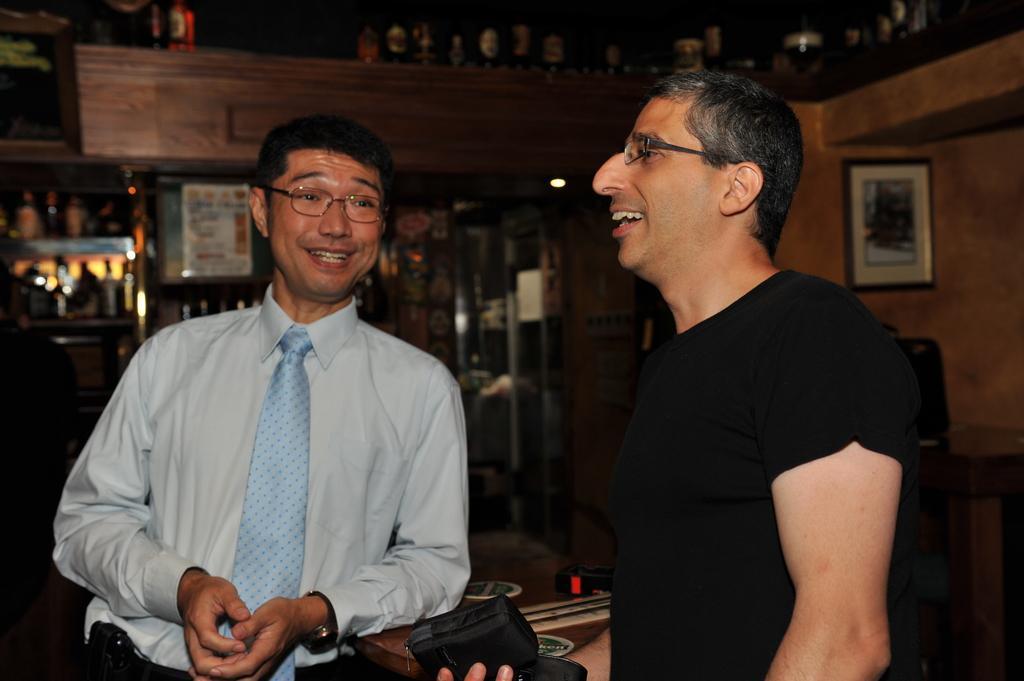How would you summarize this image in a sentence or two? In this picture there is a man who is wearing spectacles, shirt and tie. On the right there is a man who is wearing t-shirt and spectacle. Both of them are smiling. On the table I can see the stickers and other objects. In the back I can see many wine bottles are kept on this racks. On the right there is a photo frame on the wall. 